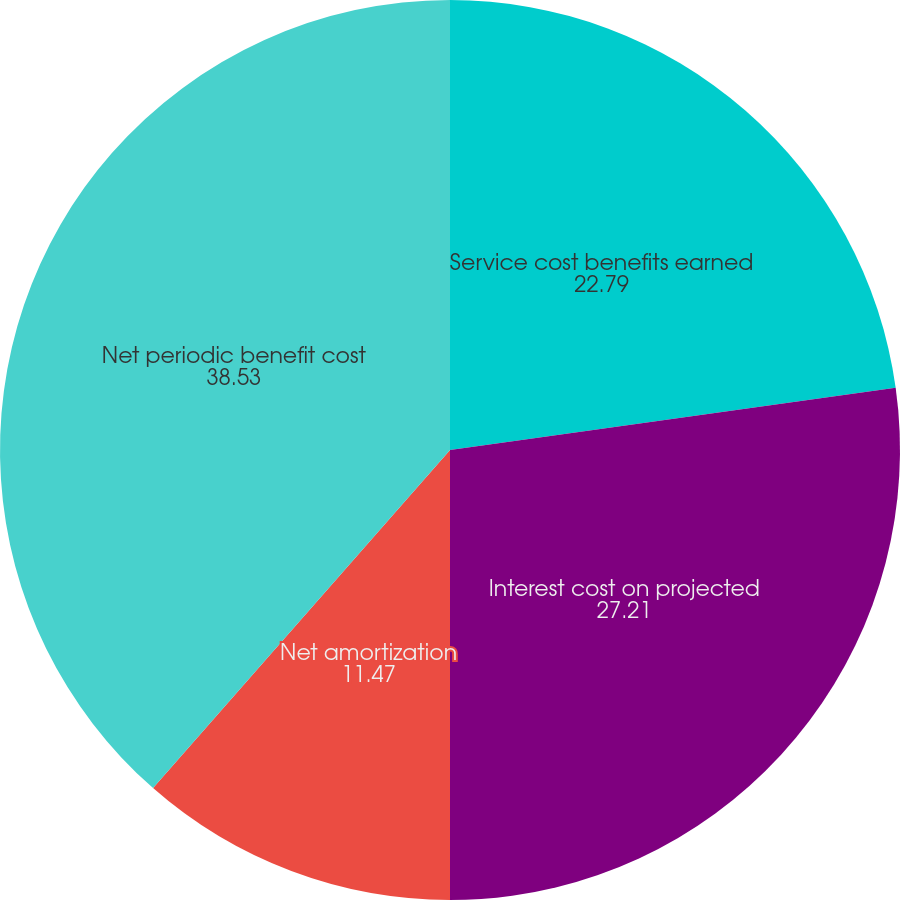<chart> <loc_0><loc_0><loc_500><loc_500><pie_chart><fcel>Service cost benefits earned<fcel>Interest cost on projected<fcel>Net amortization<fcel>Net periodic benefit cost<nl><fcel>22.79%<fcel>27.21%<fcel>11.47%<fcel>38.53%<nl></chart> 